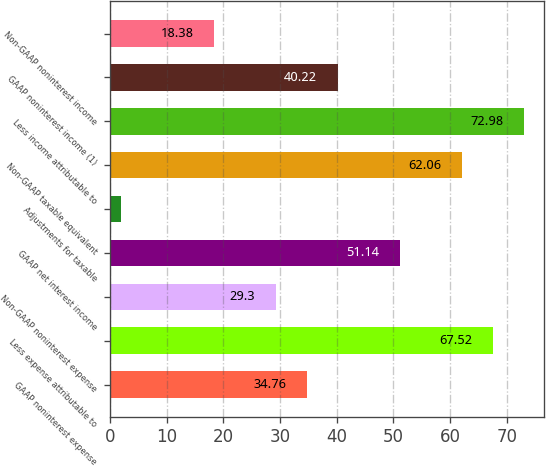Convert chart. <chart><loc_0><loc_0><loc_500><loc_500><bar_chart><fcel>GAAP noninterest expense<fcel>Less expense attributable to<fcel>Non-GAAP noninterest expense<fcel>GAAP net interest income<fcel>Adjustments for taxable<fcel>Non-GAAP taxable equivalent<fcel>Less income attributable to<fcel>GAAP noninterest income (1)<fcel>Non-GAAP noninterest income<nl><fcel>34.76<fcel>67.52<fcel>29.3<fcel>51.14<fcel>2<fcel>62.06<fcel>72.98<fcel>40.22<fcel>18.38<nl></chart> 